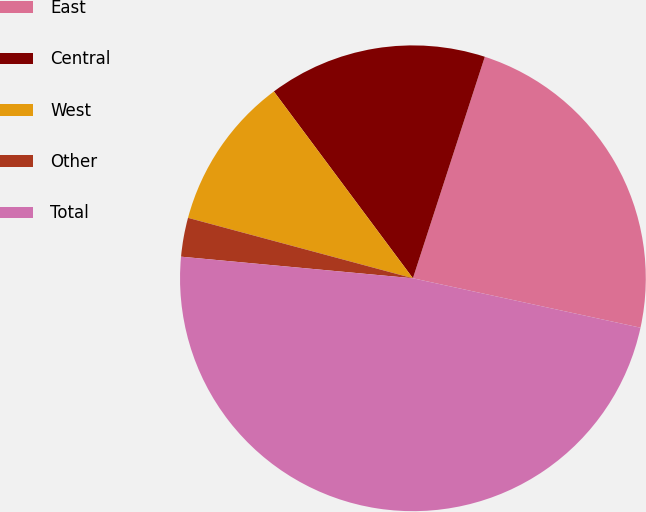Convert chart. <chart><loc_0><loc_0><loc_500><loc_500><pie_chart><fcel>East<fcel>Central<fcel>West<fcel>Other<fcel>Total<nl><fcel>23.41%<fcel>15.18%<fcel>10.64%<fcel>2.7%<fcel>48.08%<nl></chart> 